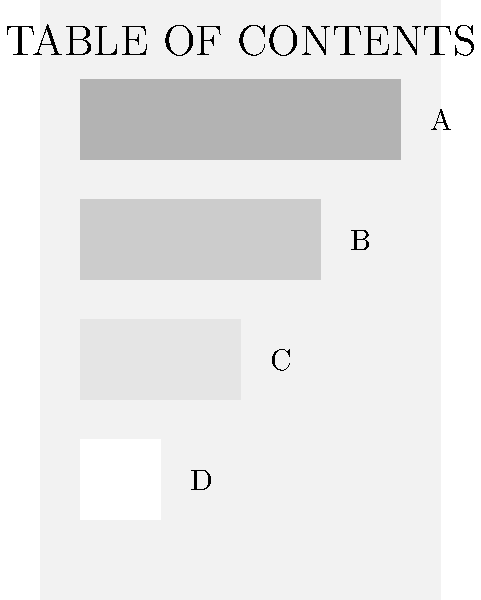In the given table of contents layout, which element (A, B, C, or D) should be given the highest visual priority to create an effective visual hierarchy? To create an effective visual hierarchy in a magazine table of contents layout, we need to consider the following steps:

1. Understand the purpose: The table of contents should guide readers to the most important or featured content first.

2. Analyze the visual elements: In this layout, we have four content blocks (A, B, C, and D) of decreasing size and varying shades.

3. Consider size: Larger elements naturally draw more attention. In this case, block A is the largest.

4. Evaluate contrast: Darker shades tend to stand out more against a light background. Block A has the darkest shade among the four.

5. Assess positioning: Elements placed higher on the page often receive more attention. Block A is positioned at the top of the content area.

6. Think about reader expectations: Readers typically expect the most important content to be featured prominently at the beginning of a table of contents.

7. Combine factors: Block A has the largest size, darkest shade, and topmost position, making it the most visually prominent element.

8. Consider hierarchy: The decreasing size and lightening shades of blocks B, C, and D create a natural visual hierarchy below A.

Given these considerations, block A should be given the highest visual priority to create an effective visual hierarchy in this table of contents layout.
Answer: A 